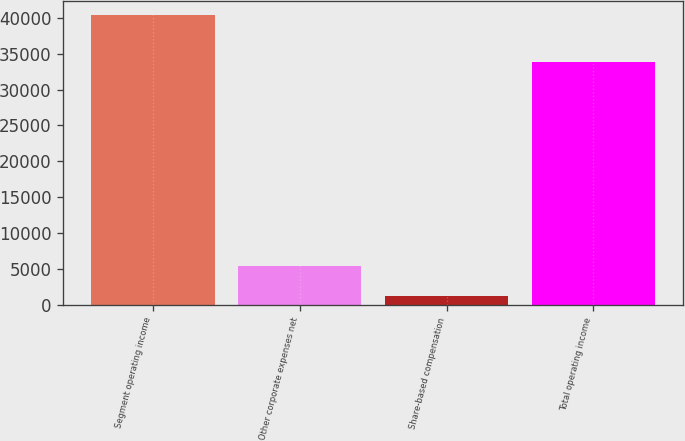Convert chart. <chart><loc_0><loc_0><loc_500><loc_500><bar_chart><fcel>Segment operating income<fcel>Other corporate expenses net<fcel>Share-based compensation<fcel>Total operating income<nl><fcel>40376<fcel>5418<fcel>1168<fcel>33790<nl></chart> 